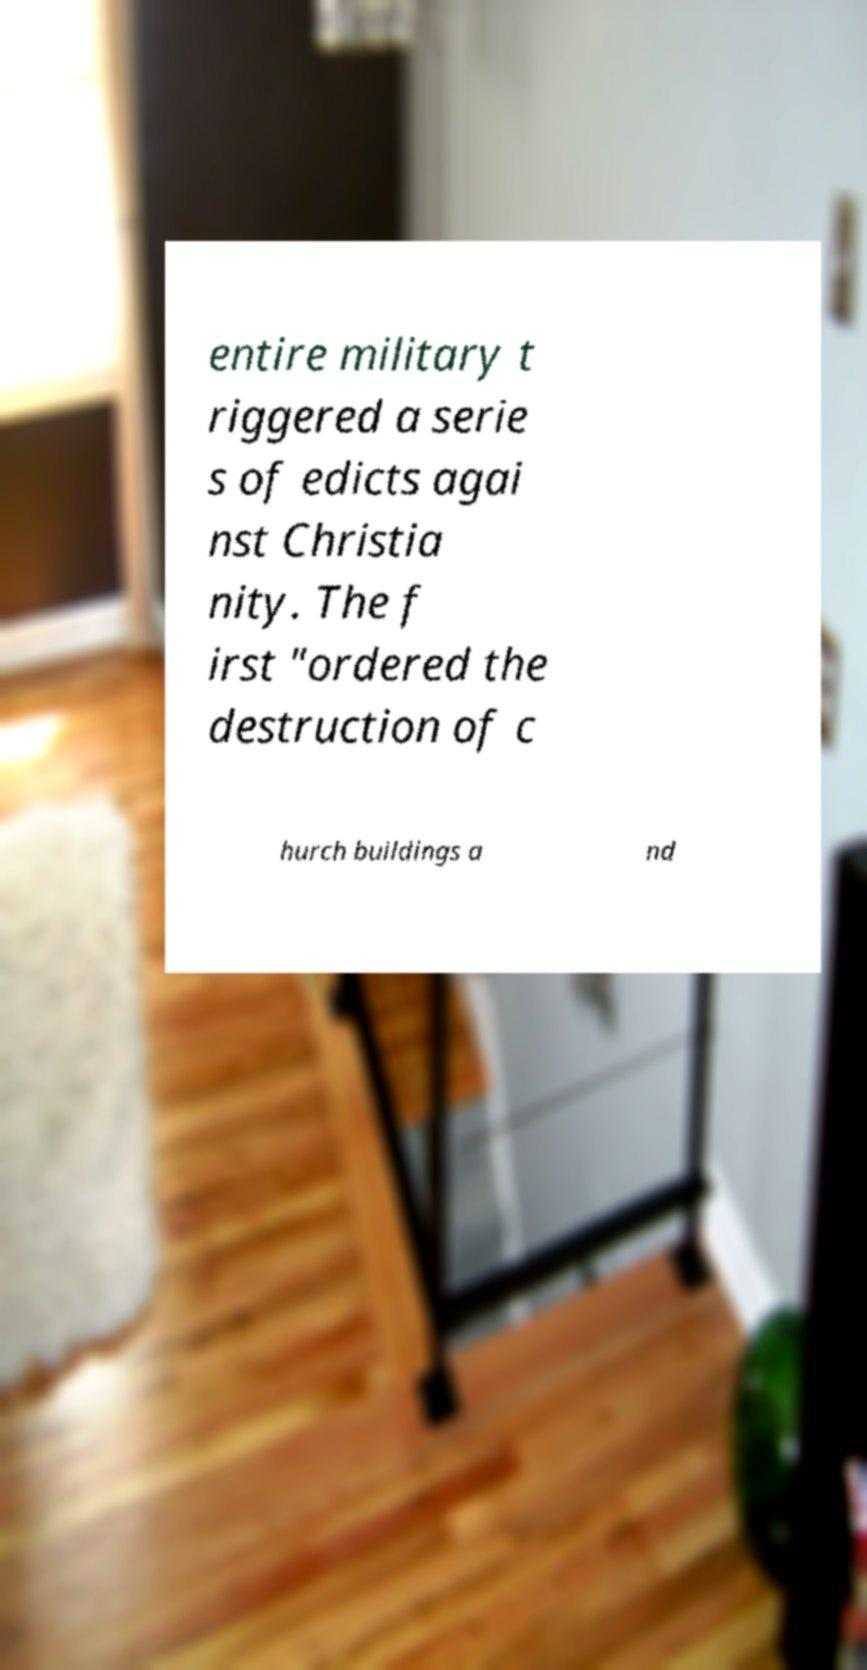What messages or text are displayed in this image? I need them in a readable, typed format. entire military t riggered a serie s of edicts agai nst Christia nity. The f irst "ordered the destruction of c hurch buildings a nd 